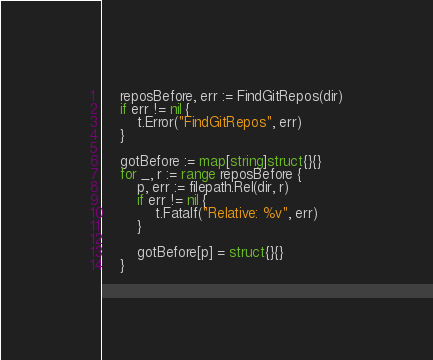Convert code to text. <code><loc_0><loc_0><loc_500><loc_500><_Go_>
	reposBefore, err := FindGitRepos(dir)
	if err != nil {
		t.Error("FindGitRepos", err)
	}

	gotBefore := map[string]struct{}{}
	for _, r := range reposBefore {
		p, err := filepath.Rel(dir, r)
		if err != nil {
			t.Fatalf("Relative: %v", err)
		}

		gotBefore[p] = struct{}{}
	}
</code> 